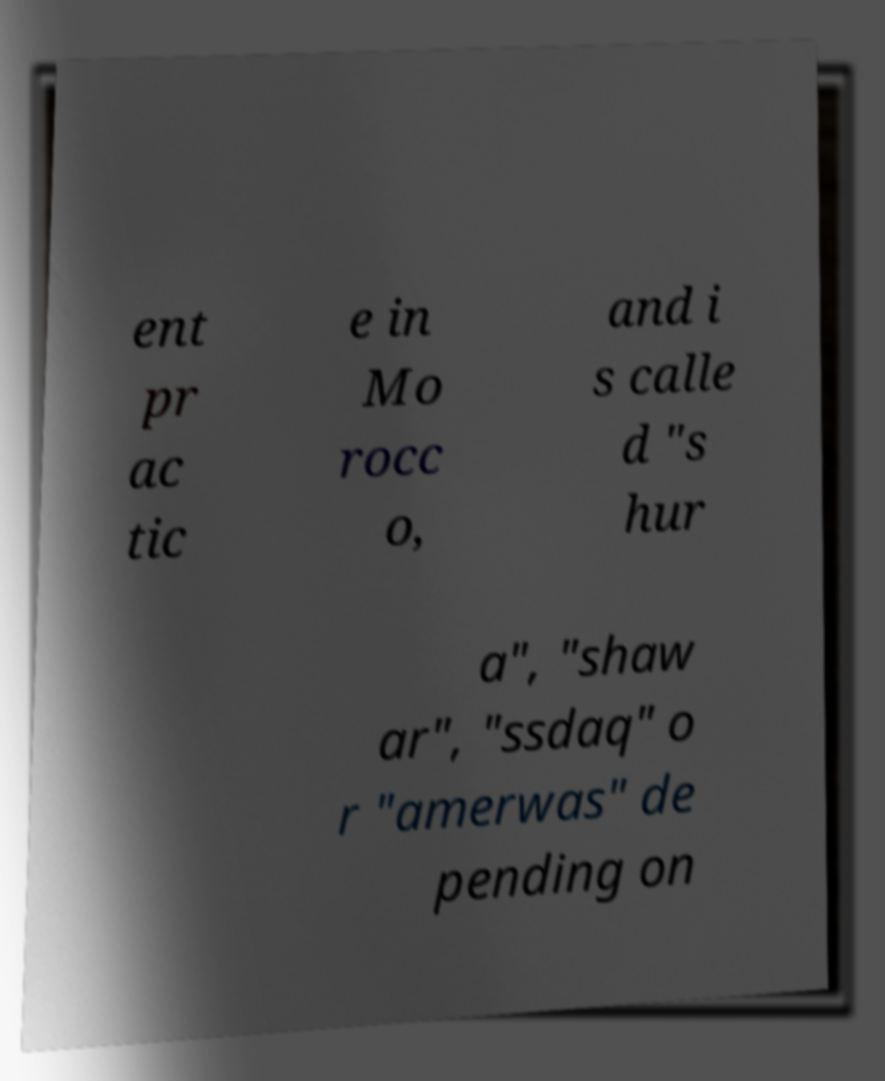Please read and relay the text visible in this image. What does it say? ent pr ac tic e in Mo rocc o, and i s calle d "s hur a", "shaw ar", "ssdaq" o r "amerwas" de pending on 